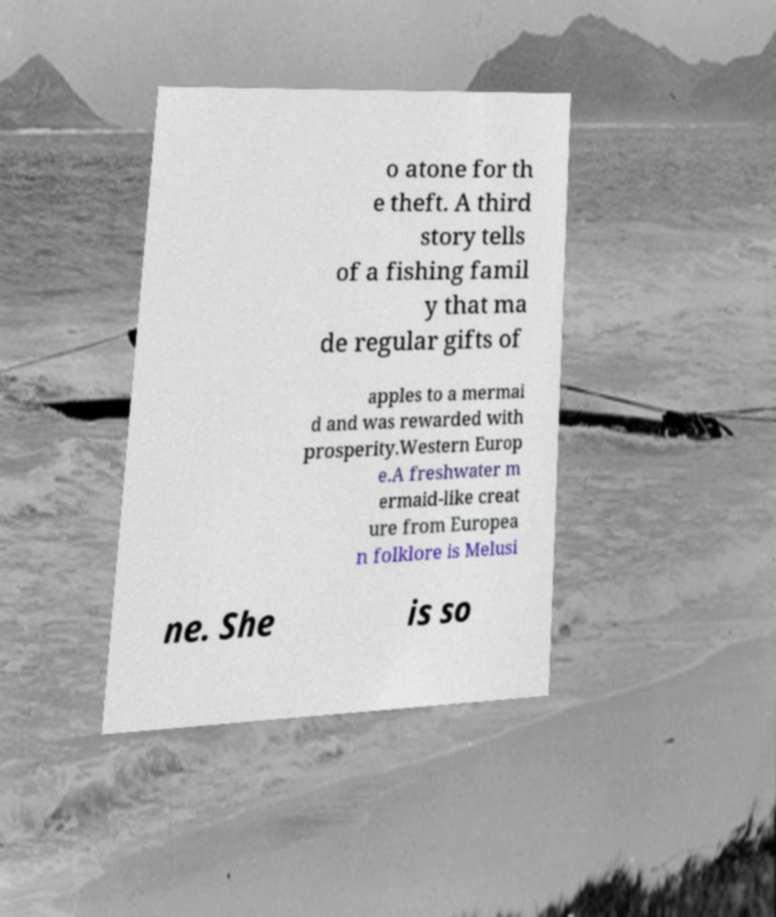Please identify and transcribe the text found in this image. o atone for th e theft. A third story tells of a fishing famil y that ma de regular gifts of apples to a mermai d and was rewarded with prosperity.Western Europ e.A freshwater m ermaid-like creat ure from Europea n folklore is Melusi ne. She is so 